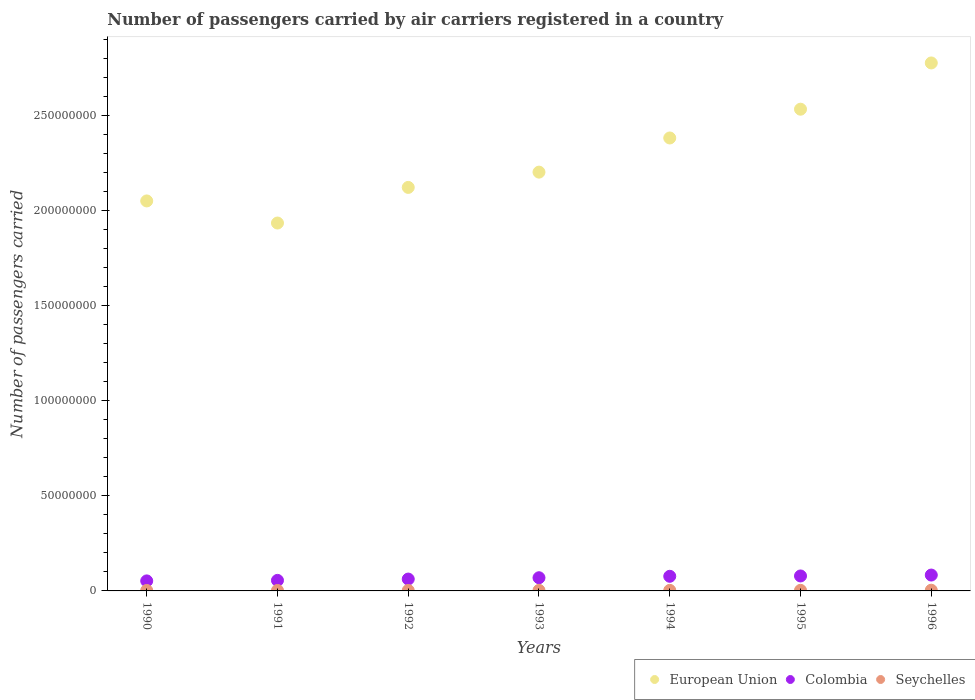How many different coloured dotlines are there?
Your response must be concise. 3. Is the number of dotlines equal to the number of legend labels?
Offer a very short reply. Yes. What is the number of passengers carried by air carriers in Colombia in 1992?
Your answer should be very brief. 6.23e+06. Across all years, what is the maximum number of passengers carried by air carriers in Colombia?
Offer a terse response. 8.34e+06. Across all years, what is the minimum number of passengers carried by air carriers in Seychelles?
Offer a very short reply. 2.40e+05. What is the total number of passengers carried by air carriers in Seychelles in the graph?
Keep it short and to the point. 2.00e+06. What is the difference between the number of passengers carried by air carriers in Seychelles in 1993 and that in 1996?
Give a very brief answer. -8.39e+04. What is the difference between the number of passengers carried by air carriers in European Union in 1991 and the number of passengers carried by air carriers in Seychelles in 1992?
Make the answer very short. 1.93e+08. What is the average number of passengers carried by air carriers in Colombia per year?
Offer a terse response. 6.84e+06. In the year 1991, what is the difference between the number of passengers carried by air carriers in Seychelles and number of passengers carried by air carriers in European Union?
Offer a very short reply. -1.93e+08. In how many years, is the number of passengers carried by air carriers in Seychelles greater than 230000000?
Offer a very short reply. 0. What is the ratio of the number of passengers carried by air carriers in European Union in 1994 to that in 1995?
Keep it short and to the point. 0.94. What is the difference between the highest and the second highest number of passengers carried by air carriers in Colombia?
Offer a very short reply. 4.79e+05. What is the difference between the highest and the lowest number of passengers carried by air carriers in Seychelles?
Ensure brevity in your answer.  1.34e+05. Is the sum of the number of passengers carried by air carriers in Colombia in 1994 and 1996 greater than the maximum number of passengers carried by air carriers in Seychelles across all years?
Give a very brief answer. Yes. Is it the case that in every year, the sum of the number of passengers carried by air carriers in Seychelles and number of passengers carried by air carriers in Colombia  is greater than the number of passengers carried by air carriers in European Union?
Your answer should be compact. No. Does the number of passengers carried by air carriers in Seychelles monotonically increase over the years?
Ensure brevity in your answer.  No. Is the number of passengers carried by air carriers in Colombia strictly greater than the number of passengers carried by air carriers in European Union over the years?
Provide a short and direct response. No. How many years are there in the graph?
Provide a short and direct response. 7. Does the graph contain any zero values?
Your answer should be compact. No. Does the graph contain grids?
Give a very brief answer. No. Where does the legend appear in the graph?
Ensure brevity in your answer.  Bottom right. How are the legend labels stacked?
Ensure brevity in your answer.  Horizontal. What is the title of the graph?
Keep it short and to the point. Number of passengers carried by air carriers registered in a country. What is the label or title of the X-axis?
Make the answer very short. Years. What is the label or title of the Y-axis?
Make the answer very short. Number of passengers carried. What is the Number of passengers carried in European Union in 1990?
Provide a short and direct response. 2.05e+08. What is the Number of passengers carried of Colombia in 1990?
Your answer should be compact. 5.27e+06. What is the Number of passengers carried in Seychelles in 1990?
Offer a very short reply. 2.42e+05. What is the Number of passengers carried in European Union in 1991?
Your answer should be very brief. 1.93e+08. What is the Number of passengers carried of Colombia in 1991?
Provide a short and direct response. 5.54e+06. What is the Number of passengers carried of Seychelles in 1991?
Make the answer very short. 2.43e+05. What is the Number of passengers carried of European Union in 1992?
Make the answer very short. 2.12e+08. What is the Number of passengers carried of Colombia in 1992?
Your answer should be compact. 6.23e+06. What is the Number of passengers carried of Seychelles in 1992?
Ensure brevity in your answer.  2.40e+05. What is the Number of passengers carried in European Union in 1993?
Your response must be concise. 2.20e+08. What is the Number of passengers carried in Colombia in 1993?
Provide a succinct answer. 6.93e+06. What is the Number of passengers carried of Seychelles in 1993?
Keep it short and to the point. 2.89e+05. What is the Number of passengers carried of European Union in 1994?
Keep it short and to the point. 2.38e+08. What is the Number of passengers carried of Colombia in 1994?
Keep it short and to the point. 7.69e+06. What is the Number of passengers carried of Seychelles in 1994?
Your answer should be very brief. 2.97e+05. What is the Number of passengers carried in European Union in 1995?
Your answer should be compact. 2.53e+08. What is the Number of passengers carried of Colombia in 1995?
Your response must be concise. 7.86e+06. What is the Number of passengers carried in Seychelles in 1995?
Keep it short and to the point. 3.14e+05. What is the Number of passengers carried in European Union in 1996?
Provide a short and direct response. 2.78e+08. What is the Number of passengers carried in Colombia in 1996?
Your answer should be compact. 8.34e+06. What is the Number of passengers carried in Seychelles in 1996?
Your response must be concise. 3.73e+05. Across all years, what is the maximum Number of passengers carried in European Union?
Provide a succinct answer. 2.78e+08. Across all years, what is the maximum Number of passengers carried in Colombia?
Offer a terse response. 8.34e+06. Across all years, what is the maximum Number of passengers carried of Seychelles?
Your answer should be very brief. 3.73e+05. Across all years, what is the minimum Number of passengers carried in European Union?
Ensure brevity in your answer.  1.93e+08. Across all years, what is the minimum Number of passengers carried in Colombia?
Offer a very short reply. 5.27e+06. Across all years, what is the minimum Number of passengers carried in Seychelles?
Give a very brief answer. 2.40e+05. What is the total Number of passengers carried in European Union in the graph?
Your response must be concise. 1.60e+09. What is the total Number of passengers carried of Colombia in the graph?
Ensure brevity in your answer.  4.79e+07. What is the total Number of passengers carried of Seychelles in the graph?
Your answer should be compact. 2.00e+06. What is the difference between the Number of passengers carried of European Union in 1990 and that in 1991?
Your answer should be very brief. 1.16e+07. What is the difference between the Number of passengers carried of Colombia in 1990 and that in 1991?
Provide a short and direct response. -2.73e+05. What is the difference between the Number of passengers carried of Seychelles in 1990 and that in 1991?
Your response must be concise. -200. What is the difference between the Number of passengers carried in European Union in 1990 and that in 1992?
Your answer should be very brief. -7.11e+06. What is the difference between the Number of passengers carried of Colombia in 1990 and that in 1992?
Provide a short and direct response. -9.65e+05. What is the difference between the Number of passengers carried of Seychelles in 1990 and that in 1992?
Provide a short and direct response. 2900. What is the difference between the Number of passengers carried of European Union in 1990 and that in 1993?
Offer a terse response. -1.51e+07. What is the difference between the Number of passengers carried of Colombia in 1990 and that in 1993?
Offer a terse response. -1.66e+06. What is the difference between the Number of passengers carried of Seychelles in 1990 and that in 1993?
Ensure brevity in your answer.  -4.69e+04. What is the difference between the Number of passengers carried of European Union in 1990 and that in 1994?
Your response must be concise. -3.31e+07. What is the difference between the Number of passengers carried of Colombia in 1990 and that in 1994?
Offer a terse response. -2.42e+06. What is the difference between the Number of passengers carried of Seychelles in 1990 and that in 1994?
Offer a terse response. -5.50e+04. What is the difference between the Number of passengers carried of European Union in 1990 and that in 1995?
Offer a terse response. -4.82e+07. What is the difference between the Number of passengers carried in Colombia in 1990 and that in 1995?
Ensure brevity in your answer.  -2.60e+06. What is the difference between the Number of passengers carried in Seychelles in 1990 and that in 1995?
Provide a short and direct response. -7.16e+04. What is the difference between the Number of passengers carried in European Union in 1990 and that in 1996?
Ensure brevity in your answer.  -7.25e+07. What is the difference between the Number of passengers carried in Colombia in 1990 and that in 1996?
Give a very brief answer. -3.08e+06. What is the difference between the Number of passengers carried of Seychelles in 1990 and that in 1996?
Your answer should be compact. -1.31e+05. What is the difference between the Number of passengers carried of European Union in 1991 and that in 1992?
Provide a short and direct response. -1.87e+07. What is the difference between the Number of passengers carried of Colombia in 1991 and that in 1992?
Make the answer very short. -6.92e+05. What is the difference between the Number of passengers carried in Seychelles in 1991 and that in 1992?
Provide a short and direct response. 3100. What is the difference between the Number of passengers carried in European Union in 1991 and that in 1993?
Offer a terse response. -2.68e+07. What is the difference between the Number of passengers carried in Colombia in 1991 and that in 1993?
Ensure brevity in your answer.  -1.39e+06. What is the difference between the Number of passengers carried in Seychelles in 1991 and that in 1993?
Give a very brief answer. -4.67e+04. What is the difference between the Number of passengers carried of European Union in 1991 and that in 1994?
Keep it short and to the point. -4.47e+07. What is the difference between the Number of passengers carried in Colombia in 1991 and that in 1994?
Your answer should be very brief. -2.15e+06. What is the difference between the Number of passengers carried of Seychelles in 1991 and that in 1994?
Give a very brief answer. -5.48e+04. What is the difference between the Number of passengers carried in European Union in 1991 and that in 1995?
Your answer should be compact. -5.98e+07. What is the difference between the Number of passengers carried in Colombia in 1991 and that in 1995?
Ensure brevity in your answer.  -2.32e+06. What is the difference between the Number of passengers carried of Seychelles in 1991 and that in 1995?
Your response must be concise. -7.14e+04. What is the difference between the Number of passengers carried of European Union in 1991 and that in 1996?
Ensure brevity in your answer.  -8.41e+07. What is the difference between the Number of passengers carried of Colombia in 1991 and that in 1996?
Your answer should be compact. -2.80e+06. What is the difference between the Number of passengers carried of Seychelles in 1991 and that in 1996?
Your answer should be very brief. -1.31e+05. What is the difference between the Number of passengers carried in European Union in 1992 and that in 1993?
Provide a succinct answer. -8.04e+06. What is the difference between the Number of passengers carried in Colombia in 1992 and that in 1993?
Your answer should be very brief. -6.98e+05. What is the difference between the Number of passengers carried in Seychelles in 1992 and that in 1993?
Give a very brief answer. -4.98e+04. What is the difference between the Number of passengers carried of European Union in 1992 and that in 1994?
Your answer should be very brief. -2.60e+07. What is the difference between the Number of passengers carried of Colombia in 1992 and that in 1994?
Your answer should be very brief. -1.45e+06. What is the difference between the Number of passengers carried in Seychelles in 1992 and that in 1994?
Give a very brief answer. -5.79e+04. What is the difference between the Number of passengers carried in European Union in 1992 and that in 1995?
Provide a short and direct response. -4.11e+07. What is the difference between the Number of passengers carried of Colombia in 1992 and that in 1995?
Offer a very short reply. -1.63e+06. What is the difference between the Number of passengers carried in Seychelles in 1992 and that in 1995?
Provide a short and direct response. -7.45e+04. What is the difference between the Number of passengers carried in European Union in 1992 and that in 1996?
Offer a very short reply. -6.54e+07. What is the difference between the Number of passengers carried of Colombia in 1992 and that in 1996?
Make the answer very short. -2.11e+06. What is the difference between the Number of passengers carried in Seychelles in 1992 and that in 1996?
Your answer should be very brief. -1.34e+05. What is the difference between the Number of passengers carried of European Union in 1993 and that in 1994?
Offer a very short reply. -1.80e+07. What is the difference between the Number of passengers carried of Colombia in 1993 and that in 1994?
Your answer should be very brief. -7.56e+05. What is the difference between the Number of passengers carried in Seychelles in 1993 and that in 1994?
Keep it short and to the point. -8100. What is the difference between the Number of passengers carried of European Union in 1993 and that in 1995?
Ensure brevity in your answer.  -3.31e+07. What is the difference between the Number of passengers carried in Colombia in 1993 and that in 1995?
Offer a terse response. -9.33e+05. What is the difference between the Number of passengers carried in Seychelles in 1993 and that in 1995?
Ensure brevity in your answer.  -2.47e+04. What is the difference between the Number of passengers carried in European Union in 1993 and that in 1996?
Keep it short and to the point. -5.74e+07. What is the difference between the Number of passengers carried in Colombia in 1993 and that in 1996?
Make the answer very short. -1.41e+06. What is the difference between the Number of passengers carried in Seychelles in 1993 and that in 1996?
Offer a terse response. -8.39e+04. What is the difference between the Number of passengers carried of European Union in 1994 and that in 1995?
Your answer should be very brief. -1.51e+07. What is the difference between the Number of passengers carried in Colombia in 1994 and that in 1995?
Your answer should be compact. -1.77e+05. What is the difference between the Number of passengers carried of Seychelles in 1994 and that in 1995?
Offer a terse response. -1.66e+04. What is the difference between the Number of passengers carried of European Union in 1994 and that in 1996?
Your response must be concise. -3.94e+07. What is the difference between the Number of passengers carried of Colombia in 1994 and that in 1996?
Your response must be concise. -6.56e+05. What is the difference between the Number of passengers carried in Seychelles in 1994 and that in 1996?
Provide a short and direct response. -7.58e+04. What is the difference between the Number of passengers carried in European Union in 1995 and that in 1996?
Make the answer very short. -2.43e+07. What is the difference between the Number of passengers carried of Colombia in 1995 and that in 1996?
Offer a very short reply. -4.79e+05. What is the difference between the Number of passengers carried in Seychelles in 1995 and that in 1996?
Keep it short and to the point. -5.92e+04. What is the difference between the Number of passengers carried of European Union in 1990 and the Number of passengers carried of Colombia in 1991?
Offer a very short reply. 1.99e+08. What is the difference between the Number of passengers carried of European Union in 1990 and the Number of passengers carried of Seychelles in 1991?
Offer a very short reply. 2.05e+08. What is the difference between the Number of passengers carried of Colombia in 1990 and the Number of passengers carried of Seychelles in 1991?
Offer a terse response. 5.02e+06. What is the difference between the Number of passengers carried of European Union in 1990 and the Number of passengers carried of Colombia in 1992?
Ensure brevity in your answer.  1.99e+08. What is the difference between the Number of passengers carried of European Union in 1990 and the Number of passengers carried of Seychelles in 1992?
Ensure brevity in your answer.  2.05e+08. What is the difference between the Number of passengers carried in Colombia in 1990 and the Number of passengers carried in Seychelles in 1992?
Your answer should be compact. 5.03e+06. What is the difference between the Number of passengers carried in European Union in 1990 and the Number of passengers carried in Colombia in 1993?
Ensure brevity in your answer.  1.98e+08. What is the difference between the Number of passengers carried of European Union in 1990 and the Number of passengers carried of Seychelles in 1993?
Your answer should be very brief. 2.05e+08. What is the difference between the Number of passengers carried in Colombia in 1990 and the Number of passengers carried in Seychelles in 1993?
Offer a terse response. 4.98e+06. What is the difference between the Number of passengers carried in European Union in 1990 and the Number of passengers carried in Colombia in 1994?
Offer a very short reply. 1.97e+08. What is the difference between the Number of passengers carried in European Union in 1990 and the Number of passengers carried in Seychelles in 1994?
Your answer should be compact. 2.05e+08. What is the difference between the Number of passengers carried in Colombia in 1990 and the Number of passengers carried in Seychelles in 1994?
Keep it short and to the point. 4.97e+06. What is the difference between the Number of passengers carried in European Union in 1990 and the Number of passengers carried in Colombia in 1995?
Provide a short and direct response. 1.97e+08. What is the difference between the Number of passengers carried in European Union in 1990 and the Number of passengers carried in Seychelles in 1995?
Provide a short and direct response. 2.05e+08. What is the difference between the Number of passengers carried of Colombia in 1990 and the Number of passengers carried of Seychelles in 1995?
Keep it short and to the point. 4.95e+06. What is the difference between the Number of passengers carried of European Union in 1990 and the Number of passengers carried of Colombia in 1996?
Your answer should be very brief. 1.97e+08. What is the difference between the Number of passengers carried in European Union in 1990 and the Number of passengers carried in Seychelles in 1996?
Provide a succinct answer. 2.05e+08. What is the difference between the Number of passengers carried of Colombia in 1990 and the Number of passengers carried of Seychelles in 1996?
Keep it short and to the point. 4.89e+06. What is the difference between the Number of passengers carried in European Union in 1991 and the Number of passengers carried in Colombia in 1992?
Your answer should be very brief. 1.87e+08. What is the difference between the Number of passengers carried in European Union in 1991 and the Number of passengers carried in Seychelles in 1992?
Ensure brevity in your answer.  1.93e+08. What is the difference between the Number of passengers carried in Colombia in 1991 and the Number of passengers carried in Seychelles in 1992?
Provide a succinct answer. 5.30e+06. What is the difference between the Number of passengers carried in European Union in 1991 and the Number of passengers carried in Colombia in 1993?
Your answer should be compact. 1.86e+08. What is the difference between the Number of passengers carried of European Union in 1991 and the Number of passengers carried of Seychelles in 1993?
Provide a succinct answer. 1.93e+08. What is the difference between the Number of passengers carried of Colombia in 1991 and the Number of passengers carried of Seychelles in 1993?
Ensure brevity in your answer.  5.25e+06. What is the difference between the Number of passengers carried of European Union in 1991 and the Number of passengers carried of Colombia in 1994?
Give a very brief answer. 1.86e+08. What is the difference between the Number of passengers carried in European Union in 1991 and the Number of passengers carried in Seychelles in 1994?
Offer a very short reply. 1.93e+08. What is the difference between the Number of passengers carried in Colombia in 1991 and the Number of passengers carried in Seychelles in 1994?
Make the answer very short. 5.24e+06. What is the difference between the Number of passengers carried in European Union in 1991 and the Number of passengers carried in Colombia in 1995?
Make the answer very short. 1.86e+08. What is the difference between the Number of passengers carried of European Union in 1991 and the Number of passengers carried of Seychelles in 1995?
Your answer should be compact. 1.93e+08. What is the difference between the Number of passengers carried in Colombia in 1991 and the Number of passengers carried in Seychelles in 1995?
Your response must be concise. 5.23e+06. What is the difference between the Number of passengers carried of European Union in 1991 and the Number of passengers carried of Colombia in 1996?
Provide a short and direct response. 1.85e+08. What is the difference between the Number of passengers carried of European Union in 1991 and the Number of passengers carried of Seychelles in 1996?
Offer a very short reply. 1.93e+08. What is the difference between the Number of passengers carried in Colombia in 1991 and the Number of passengers carried in Seychelles in 1996?
Provide a short and direct response. 5.17e+06. What is the difference between the Number of passengers carried of European Union in 1992 and the Number of passengers carried of Colombia in 1993?
Make the answer very short. 2.05e+08. What is the difference between the Number of passengers carried of European Union in 1992 and the Number of passengers carried of Seychelles in 1993?
Your answer should be compact. 2.12e+08. What is the difference between the Number of passengers carried in Colombia in 1992 and the Number of passengers carried in Seychelles in 1993?
Offer a terse response. 5.94e+06. What is the difference between the Number of passengers carried in European Union in 1992 and the Number of passengers carried in Colombia in 1994?
Provide a succinct answer. 2.04e+08. What is the difference between the Number of passengers carried in European Union in 1992 and the Number of passengers carried in Seychelles in 1994?
Keep it short and to the point. 2.12e+08. What is the difference between the Number of passengers carried of Colombia in 1992 and the Number of passengers carried of Seychelles in 1994?
Your answer should be very brief. 5.93e+06. What is the difference between the Number of passengers carried of European Union in 1992 and the Number of passengers carried of Colombia in 1995?
Your answer should be very brief. 2.04e+08. What is the difference between the Number of passengers carried in European Union in 1992 and the Number of passengers carried in Seychelles in 1995?
Ensure brevity in your answer.  2.12e+08. What is the difference between the Number of passengers carried in Colombia in 1992 and the Number of passengers carried in Seychelles in 1995?
Give a very brief answer. 5.92e+06. What is the difference between the Number of passengers carried of European Union in 1992 and the Number of passengers carried of Colombia in 1996?
Offer a terse response. 2.04e+08. What is the difference between the Number of passengers carried in European Union in 1992 and the Number of passengers carried in Seychelles in 1996?
Make the answer very short. 2.12e+08. What is the difference between the Number of passengers carried in Colombia in 1992 and the Number of passengers carried in Seychelles in 1996?
Offer a terse response. 5.86e+06. What is the difference between the Number of passengers carried of European Union in 1993 and the Number of passengers carried of Colombia in 1994?
Your answer should be compact. 2.12e+08. What is the difference between the Number of passengers carried in European Union in 1993 and the Number of passengers carried in Seychelles in 1994?
Give a very brief answer. 2.20e+08. What is the difference between the Number of passengers carried in Colombia in 1993 and the Number of passengers carried in Seychelles in 1994?
Your response must be concise. 6.63e+06. What is the difference between the Number of passengers carried of European Union in 1993 and the Number of passengers carried of Colombia in 1995?
Offer a terse response. 2.12e+08. What is the difference between the Number of passengers carried of European Union in 1993 and the Number of passengers carried of Seychelles in 1995?
Make the answer very short. 2.20e+08. What is the difference between the Number of passengers carried of Colombia in 1993 and the Number of passengers carried of Seychelles in 1995?
Provide a succinct answer. 6.62e+06. What is the difference between the Number of passengers carried in European Union in 1993 and the Number of passengers carried in Colombia in 1996?
Provide a succinct answer. 2.12e+08. What is the difference between the Number of passengers carried in European Union in 1993 and the Number of passengers carried in Seychelles in 1996?
Your response must be concise. 2.20e+08. What is the difference between the Number of passengers carried of Colombia in 1993 and the Number of passengers carried of Seychelles in 1996?
Provide a succinct answer. 6.56e+06. What is the difference between the Number of passengers carried of European Union in 1994 and the Number of passengers carried of Colombia in 1995?
Offer a terse response. 2.30e+08. What is the difference between the Number of passengers carried of European Union in 1994 and the Number of passengers carried of Seychelles in 1995?
Keep it short and to the point. 2.38e+08. What is the difference between the Number of passengers carried of Colombia in 1994 and the Number of passengers carried of Seychelles in 1995?
Offer a terse response. 7.37e+06. What is the difference between the Number of passengers carried of European Union in 1994 and the Number of passengers carried of Colombia in 1996?
Offer a terse response. 2.30e+08. What is the difference between the Number of passengers carried in European Union in 1994 and the Number of passengers carried in Seychelles in 1996?
Your answer should be very brief. 2.38e+08. What is the difference between the Number of passengers carried in Colombia in 1994 and the Number of passengers carried in Seychelles in 1996?
Your response must be concise. 7.31e+06. What is the difference between the Number of passengers carried in European Union in 1995 and the Number of passengers carried in Colombia in 1996?
Your response must be concise. 2.45e+08. What is the difference between the Number of passengers carried of European Union in 1995 and the Number of passengers carried of Seychelles in 1996?
Provide a short and direct response. 2.53e+08. What is the difference between the Number of passengers carried of Colombia in 1995 and the Number of passengers carried of Seychelles in 1996?
Provide a succinct answer. 7.49e+06. What is the average Number of passengers carried in European Union per year?
Offer a very short reply. 2.29e+08. What is the average Number of passengers carried in Colombia per year?
Ensure brevity in your answer.  6.84e+06. What is the average Number of passengers carried in Seychelles per year?
Your answer should be very brief. 2.85e+05. In the year 1990, what is the difference between the Number of passengers carried of European Union and Number of passengers carried of Colombia?
Keep it short and to the point. 2.00e+08. In the year 1990, what is the difference between the Number of passengers carried in European Union and Number of passengers carried in Seychelles?
Your answer should be very brief. 2.05e+08. In the year 1990, what is the difference between the Number of passengers carried of Colombia and Number of passengers carried of Seychelles?
Give a very brief answer. 5.02e+06. In the year 1991, what is the difference between the Number of passengers carried in European Union and Number of passengers carried in Colombia?
Give a very brief answer. 1.88e+08. In the year 1991, what is the difference between the Number of passengers carried in European Union and Number of passengers carried in Seychelles?
Give a very brief answer. 1.93e+08. In the year 1991, what is the difference between the Number of passengers carried in Colombia and Number of passengers carried in Seychelles?
Keep it short and to the point. 5.30e+06. In the year 1992, what is the difference between the Number of passengers carried in European Union and Number of passengers carried in Colombia?
Your answer should be compact. 2.06e+08. In the year 1992, what is the difference between the Number of passengers carried of European Union and Number of passengers carried of Seychelles?
Offer a terse response. 2.12e+08. In the year 1992, what is the difference between the Number of passengers carried in Colombia and Number of passengers carried in Seychelles?
Ensure brevity in your answer.  5.99e+06. In the year 1993, what is the difference between the Number of passengers carried in European Union and Number of passengers carried in Colombia?
Your answer should be very brief. 2.13e+08. In the year 1993, what is the difference between the Number of passengers carried of European Union and Number of passengers carried of Seychelles?
Offer a terse response. 2.20e+08. In the year 1993, what is the difference between the Number of passengers carried in Colombia and Number of passengers carried in Seychelles?
Keep it short and to the point. 6.64e+06. In the year 1994, what is the difference between the Number of passengers carried of European Union and Number of passengers carried of Colombia?
Provide a short and direct response. 2.30e+08. In the year 1994, what is the difference between the Number of passengers carried of European Union and Number of passengers carried of Seychelles?
Keep it short and to the point. 2.38e+08. In the year 1994, what is the difference between the Number of passengers carried in Colombia and Number of passengers carried in Seychelles?
Provide a short and direct response. 7.39e+06. In the year 1995, what is the difference between the Number of passengers carried of European Union and Number of passengers carried of Colombia?
Your response must be concise. 2.45e+08. In the year 1995, what is the difference between the Number of passengers carried of European Union and Number of passengers carried of Seychelles?
Your answer should be very brief. 2.53e+08. In the year 1995, what is the difference between the Number of passengers carried of Colombia and Number of passengers carried of Seychelles?
Ensure brevity in your answer.  7.55e+06. In the year 1996, what is the difference between the Number of passengers carried in European Union and Number of passengers carried in Colombia?
Give a very brief answer. 2.69e+08. In the year 1996, what is the difference between the Number of passengers carried in European Union and Number of passengers carried in Seychelles?
Keep it short and to the point. 2.77e+08. In the year 1996, what is the difference between the Number of passengers carried in Colombia and Number of passengers carried in Seychelles?
Offer a very short reply. 7.97e+06. What is the ratio of the Number of passengers carried in European Union in 1990 to that in 1991?
Your response must be concise. 1.06. What is the ratio of the Number of passengers carried in Colombia in 1990 to that in 1991?
Offer a terse response. 0.95. What is the ratio of the Number of passengers carried in Seychelles in 1990 to that in 1991?
Make the answer very short. 1. What is the ratio of the Number of passengers carried of European Union in 1990 to that in 1992?
Keep it short and to the point. 0.97. What is the ratio of the Number of passengers carried in Colombia in 1990 to that in 1992?
Offer a very short reply. 0.85. What is the ratio of the Number of passengers carried in Seychelles in 1990 to that in 1992?
Keep it short and to the point. 1.01. What is the ratio of the Number of passengers carried in European Union in 1990 to that in 1993?
Provide a succinct answer. 0.93. What is the ratio of the Number of passengers carried in Colombia in 1990 to that in 1993?
Provide a succinct answer. 0.76. What is the ratio of the Number of passengers carried of Seychelles in 1990 to that in 1993?
Provide a short and direct response. 0.84. What is the ratio of the Number of passengers carried of European Union in 1990 to that in 1994?
Your answer should be compact. 0.86. What is the ratio of the Number of passengers carried in Colombia in 1990 to that in 1994?
Your response must be concise. 0.69. What is the ratio of the Number of passengers carried in Seychelles in 1990 to that in 1994?
Your response must be concise. 0.82. What is the ratio of the Number of passengers carried of European Union in 1990 to that in 1995?
Ensure brevity in your answer.  0.81. What is the ratio of the Number of passengers carried of Colombia in 1990 to that in 1995?
Give a very brief answer. 0.67. What is the ratio of the Number of passengers carried in Seychelles in 1990 to that in 1995?
Offer a very short reply. 0.77. What is the ratio of the Number of passengers carried of European Union in 1990 to that in 1996?
Keep it short and to the point. 0.74. What is the ratio of the Number of passengers carried in Colombia in 1990 to that in 1996?
Ensure brevity in your answer.  0.63. What is the ratio of the Number of passengers carried in Seychelles in 1990 to that in 1996?
Keep it short and to the point. 0.65. What is the ratio of the Number of passengers carried of European Union in 1991 to that in 1992?
Ensure brevity in your answer.  0.91. What is the ratio of the Number of passengers carried in Colombia in 1991 to that in 1992?
Ensure brevity in your answer.  0.89. What is the ratio of the Number of passengers carried in Seychelles in 1991 to that in 1992?
Give a very brief answer. 1.01. What is the ratio of the Number of passengers carried in European Union in 1991 to that in 1993?
Offer a terse response. 0.88. What is the ratio of the Number of passengers carried of Colombia in 1991 to that in 1993?
Your response must be concise. 0.8. What is the ratio of the Number of passengers carried in Seychelles in 1991 to that in 1993?
Offer a very short reply. 0.84. What is the ratio of the Number of passengers carried of European Union in 1991 to that in 1994?
Provide a short and direct response. 0.81. What is the ratio of the Number of passengers carried in Colombia in 1991 to that in 1994?
Your answer should be very brief. 0.72. What is the ratio of the Number of passengers carried in Seychelles in 1991 to that in 1994?
Offer a terse response. 0.82. What is the ratio of the Number of passengers carried in European Union in 1991 to that in 1995?
Keep it short and to the point. 0.76. What is the ratio of the Number of passengers carried of Colombia in 1991 to that in 1995?
Your response must be concise. 0.7. What is the ratio of the Number of passengers carried of Seychelles in 1991 to that in 1995?
Give a very brief answer. 0.77. What is the ratio of the Number of passengers carried of European Union in 1991 to that in 1996?
Offer a terse response. 0.7. What is the ratio of the Number of passengers carried in Colombia in 1991 to that in 1996?
Make the answer very short. 0.66. What is the ratio of the Number of passengers carried in Seychelles in 1991 to that in 1996?
Your answer should be compact. 0.65. What is the ratio of the Number of passengers carried in European Union in 1992 to that in 1993?
Offer a very short reply. 0.96. What is the ratio of the Number of passengers carried in Colombia in 1992 to that in 1993?
Your answer should be compact. 0.9. What is the ratio of the Number of passengers carried of Seychelles in 1992 to that in 1993?
Ensure brevity in your answer.  0.83. What is the ratio of the Number of passengers carried in European Union in 1992 to that in 1994?
Provide a short and direct response. 0.89. What is the ratio of the Number of passengers carried of Colombia in 1992 to that in 1994?
Give a very brief answer. 0.81. What is the ratio of the Number of passengers carried of Seychelles in 1992 to that in 1994?
Give a very brief answer. 0.81. What is the ratio of the Number of passengers carried of European Union in 1992 to that in 1995?
Provide a short and direct response. 0.84. What is the ratio of the Number of passengers carried in Colombia in 1992 to that in 1995?
Offer a terse response. 0.79. What is the ratio of the Number of passengers carried in Seychelles in 1992 to that in 1995?
Offer a terse response. 0.76. What is the ratio of the Number of passengers carried of European Union in 1992 to that in 1996?
Provide a short and direct response. 0.76. What is the ratio of the Number of passengers carried in Colombia in 1992 to that in 1996?
Your response must be concise. 0.75. What is the ratio of the Number of passengers carried in Seychelles in 1992 to that in 1996?
Your answer should be very brief. 0.64. What is the ratio of the Number of passengers carried of European Union in 1993 to that in 1994?
Provide a succinct answer. 0.92. What is the ratio of the Number of passengers carried of Colombia in 1993 to that in 1994?
Your response must be concise. 0.9. What is the ratio of the Number of passengers carried in Seychelles in 1993 to that in 1994?
Make the answer very short. 0.97. What is the ratio of the Number of passengers carried of European Union in 1993 to that in 1995?
Ensure brevity in your answer.  0.87. What is the ratio of the Number of passengers carried in Colombia in 1993 to that in 1995?
Ensure brevity in your answer.  0.88. What is the ratio of the Number of passengers carried in Seychelles in 1993 to that in 1995?
Give a very brief answer. 0.92. What is the ratio of the Number of passengers carried in European Union in 1993 to that in 1996?
Ensure brevity in your answer.  0.79. What is the ratio of the Number of passengers carried in Colombia in 1993 to that in 1996?
Provide a short and direct response. 0.83. What is the ratio of the Number of passengers carried of Seychelles in 1993 to that in 1996?
Your response must be concise. 0.78. What is the ratio of the Number of passengers carried of European Union in 1994 to that in 1995?
Provide a short and direct response. 0.94. What is the ratio of the Number of passengers carried in Colombia in 1994 to that in 1995?
Your answer should be compact. 0.98. What is the ratio of the Number of passengers carried in Seychelles in 1994 to that in 1995?
Your answer should be very brief. 0.95. What is the ratio of the Number of passengers carried of European Union in 1994 to that in 1996?
Offer a terse response. 0.86. What is the ratio of the Number of passengers carried of Colombia in 1994 to that in 1996?
Your answer should be very brief. 0.92. What is the ratio of the Number of passengers carried in Seychelles in 1994 to that in 1996?
Offer a terse response. 0.8. What is the ratio of the Number of passengers carried in European Union in 1995 to that in 1996?
Keep it short and to the point. 0.91. What is the ratio of the Number of passengers carried of Colombia in 1995 to that in 1996?
Your answer should be compact. 0.94. What is the ratio of the Number of passengers carried in Seychelles in 1995 to that in 1996?
Your answer should be very brief. 0.84. What is the difference between the highest and the second highest Number of passengers carried in European Union?
Ensure brevity in your answer.  2.43e+07. What is the difference between the highest and the second highest Number of passengers carried of Colombia?
Your response must be concise. 4.79e+05. What is the difference between the highest and the second highest Number of passengers carried in Seychelles?
Give a very brief answer. 5.92e+04. What is the difference between the highest and the lowest Number of passengers carried in European Union?
Your answer should be very brief. 8.41e+07. What is the difference between the highest and the lowest Number of passengers carried of Colombia?
Your answer should be compact. 3.08e+06. What is the difference between the highest and the lowest Number of passengers carried of Seychelles?
Offer a very short reply. 1.34e+05. 